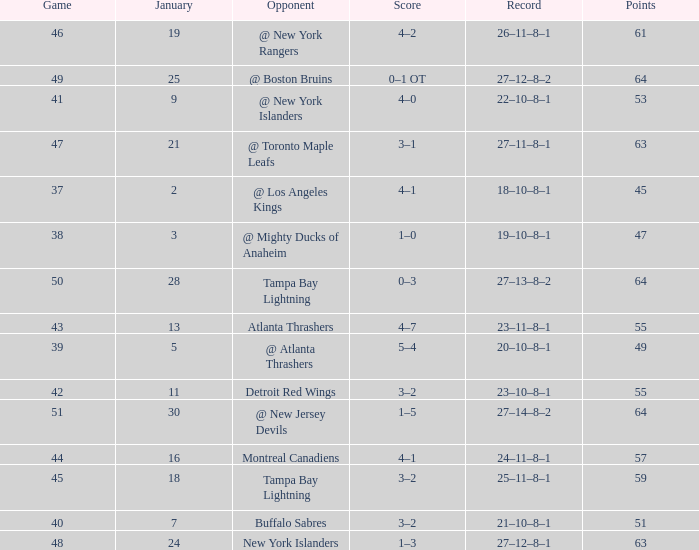Give me the full table as a dictionary. {'header': ['Game', 'January', 'Opponent', 'Score', 'Record', 'Points'], 'rows': [['46', '19', '@ New York Rangers', '4–2', '26–11–8–1', '61'], ['49', '25', '@ Boston Bruins', '0–1 OT', '27–12–8–2', '64'], ['41', '9', '@ New York Islanders', '4–0', '22–10–8–1', '53'], ['47', '21', '@ Toronto Maple Leafs', '3–1', '27–11–8–1', '63'], ['37', '2', '@ Los Angeles Kings', '4–1', '18–10–8–1', '45'], ['38', '3', '@ Mighty Ducks of Anaheim', '1–0', '19–10–8–1', '47'], ['50', '28', 'Tampa Bay Lightning', '0–3', '27–13–8–2', '64'], ['43', '13', 'Atlanta Thrashers', '4–7', '23–11–8–1', '55'], ['39', '5', '@ Atlanta Thrashers', '5–4', '20–10–8–1', '49'], ['42', '11', 'Detroit Red Wings', '3–2', '23–10–8–1', '55'], ['51', '30', '@ New Jersey Devils', '1–5', '27–14–8–2', '64'], ['44', '16', 'Montreal Canadiens', '4–1', '24–11–8–1', '57'], ['45', '18', 'Tampa Bay Lightning', '3–2', '25–11–8–1', '59'], ['40', '7', 'Buffalo Sabres', '3–2', '21–10–8–1', '51'], ['48', '24', 'New York Islanders', '1–3', '27–12–8–1', '63']]} Which Points have a Score of 4–1, and a Record of 18–10–8–1, and a January larger than 2? None. 